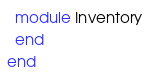Convert code to text. <code><loc_0><loc_0><loc_500><loc_500><_Ruby_>  module Inventory
  end
end
</code> 